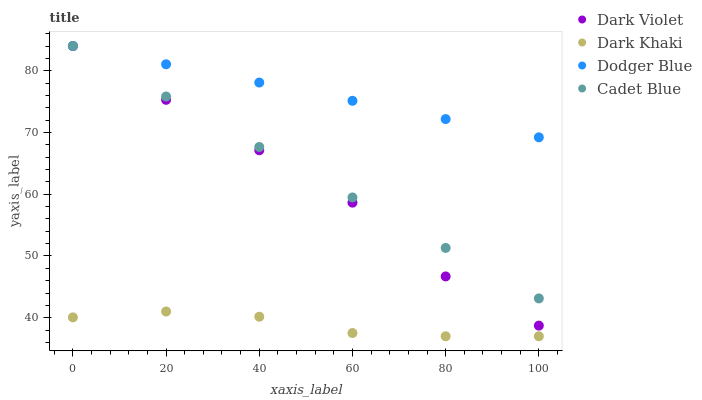Does Dark Khaki have the minimum area under the curve?
Answer yes or no. Yes. Does Dodger Blue have the maximum area under the curve?
Answer yes or no. Yes. Does Cadet Blue have the minimum area under the curve?
Answer yes or no. No. Does Cadet Blue have the maximum area under the curve?
Answer yes or no. No. Is Dodger Blue the smoothest?
Answer yes or no. Yes. Is Dark Violet the roughest?
Answer yes or no. Yes. Is Cadet Blue the smoothest?
Answer yes or no. No. Is Cadet Blue the roughest?
Answer yes or no. No. Does Dark Khaki have the lowest value?
Answer yes or no. Yes. Does Cadet Blue have the lowest value?
Answer yes or no. No. Does Dark Violet have the highest value?
Answer yes or no. Yes. Is Dark Khaki less than Cadet Blue?
Answer yes or no. Yes. Is Cadet Blue greater than Dark Khaki?
Answer yes or no. Yes. Does Dodger Blue intersect Cadet Blue?
Answer yes or no. Yes. Is Dodger Blue less than Cadet Blue?
Answer yes or no. No. Is Dodger Blue greater than Cadet Blue?
Answer yes or no. No. Does Dark Khaki intersect Cadet Blue?
Answer yes or no. No. 